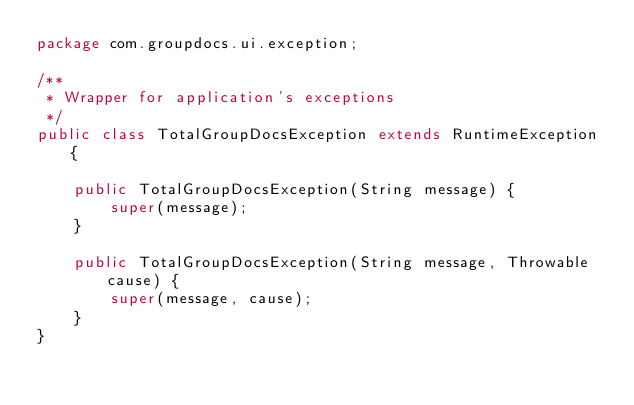Convert code to text. <code><loc_0><loc_0><loc_500><loc_500><_Java_>package com.groupdocs.ui.exception;

/**
 * Wrapper for application's exceptions
 */
public class TotalGroupDocsException extends RuntimeException {

    public TotalGroupDocsException(String message) {
        super(message);
    }

    public TotalGroupDocsException(String message, Throwable cause) {
        super(message, cause);
    }
}
</code> 